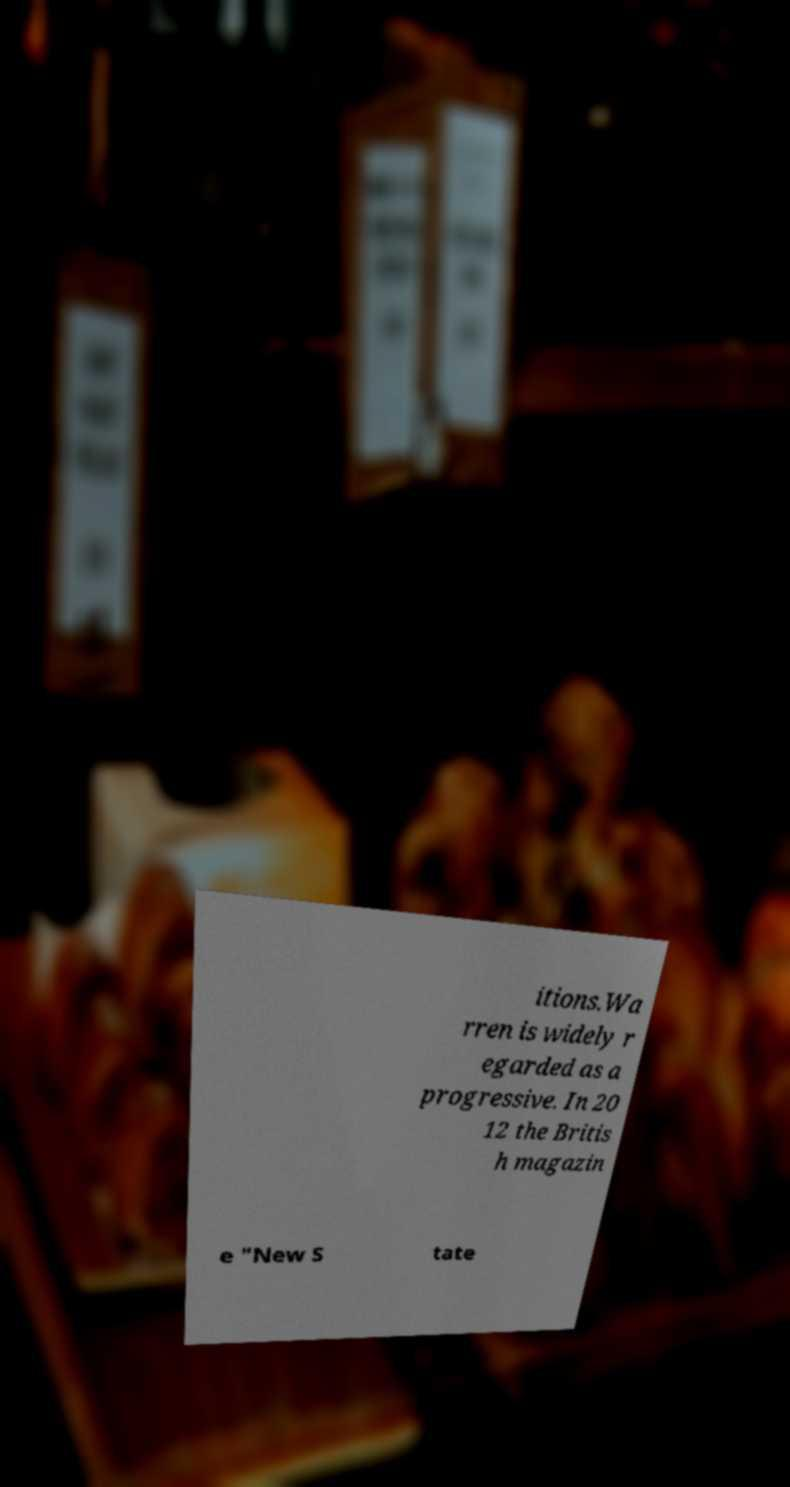Could you assist in decoding the text presented in this image and type it out clearly? itions.Wa rren is widely r egarded as a progressive. In 20 12 the Britis h magazin e "New S tate 